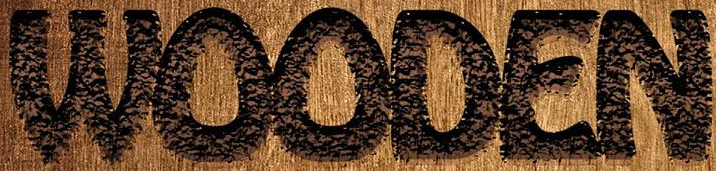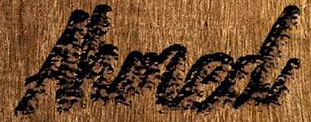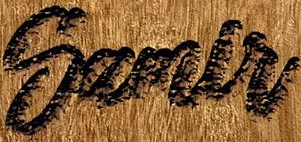What text is displayed in these images sequentially, separated by a semicolon? WOODEN; Ahmed; Samlr 